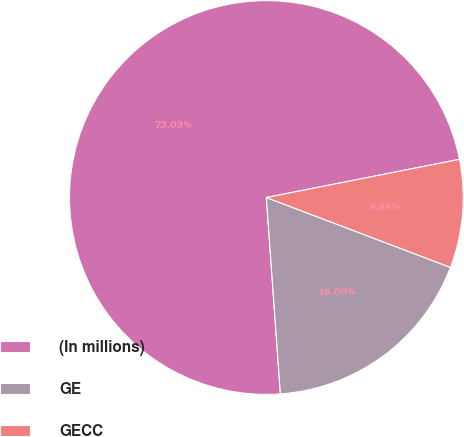<chart> <loc_0><loc_0><loc_500><loc_500><pie_chart><fcel>(In millions)<fcel>GE<fcel>GECC<nl><fcel>73.02%<fcel>18.09%<fcel>8.88%<nl></chart> 